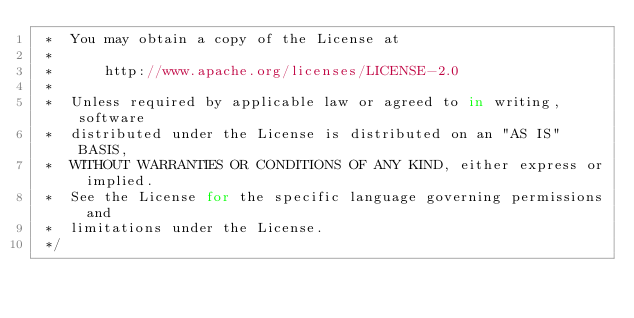Convert code to text. <code><loc_0><loc_0><loc_500><loc_500><_JavaScript_> *  You may obtain a copy of the License at
 *
 *      http://www.apache.org/licenses/LICENSE-2.0
 *
 *  Unless required by applicable law or agreed to in writing, software
 *  distributed under the License is distributed on an "AS IS" BASIS,
 *  WITHOUT WARRANTIES OR CONDITIONS OF ANY KIND, either express or implied.
 *  See the License for the specific language governing permissions and
 *  limitations under the License.
 */
</code> 